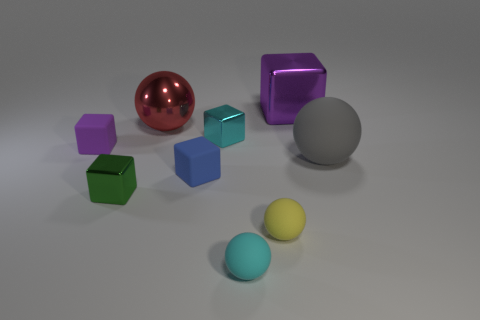Subtract all cyan cubes. How many cubes are left? 4 Subtract all cyan cubes. How many cubes are left? 4 Subtract all cyan blocks. Subtract all red balls. How many blocks are left? 4 Add 1 tiny shiny blocks. How many objects exist? 10 Subtract all spheres. How many objects are left? 5 Add 4 matte cubes. How many matte cubes exist? 6 Subtract 0 red cylinders. How many objects are left? 9 Subtract all purple shiny objects. Subtract all purple blocks. How many objects are left? 6 Add 5 large gray things. How many large gray things are left? 6 